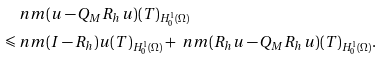<formula> <loc_0><loc_0><loc_500><loc_500>& \ n m { ( u - Q _ { M } R _ { h } u ) ( T ) } _ { H _ { 0 } ^ { 1 } ( \Omega ) } \\ \leqslant & \ n m { ( I - R _ { h } ) u ( T ) } _ { H _ { 0 } ^ { 1 } ( \Omega ) } + \ n m { ( R _ { h } u - Q _ { M } R _ { h } u ) ( T ) } _ { H _ { 0 } ^ { 1 } ( \Omega ) } .</formula> 